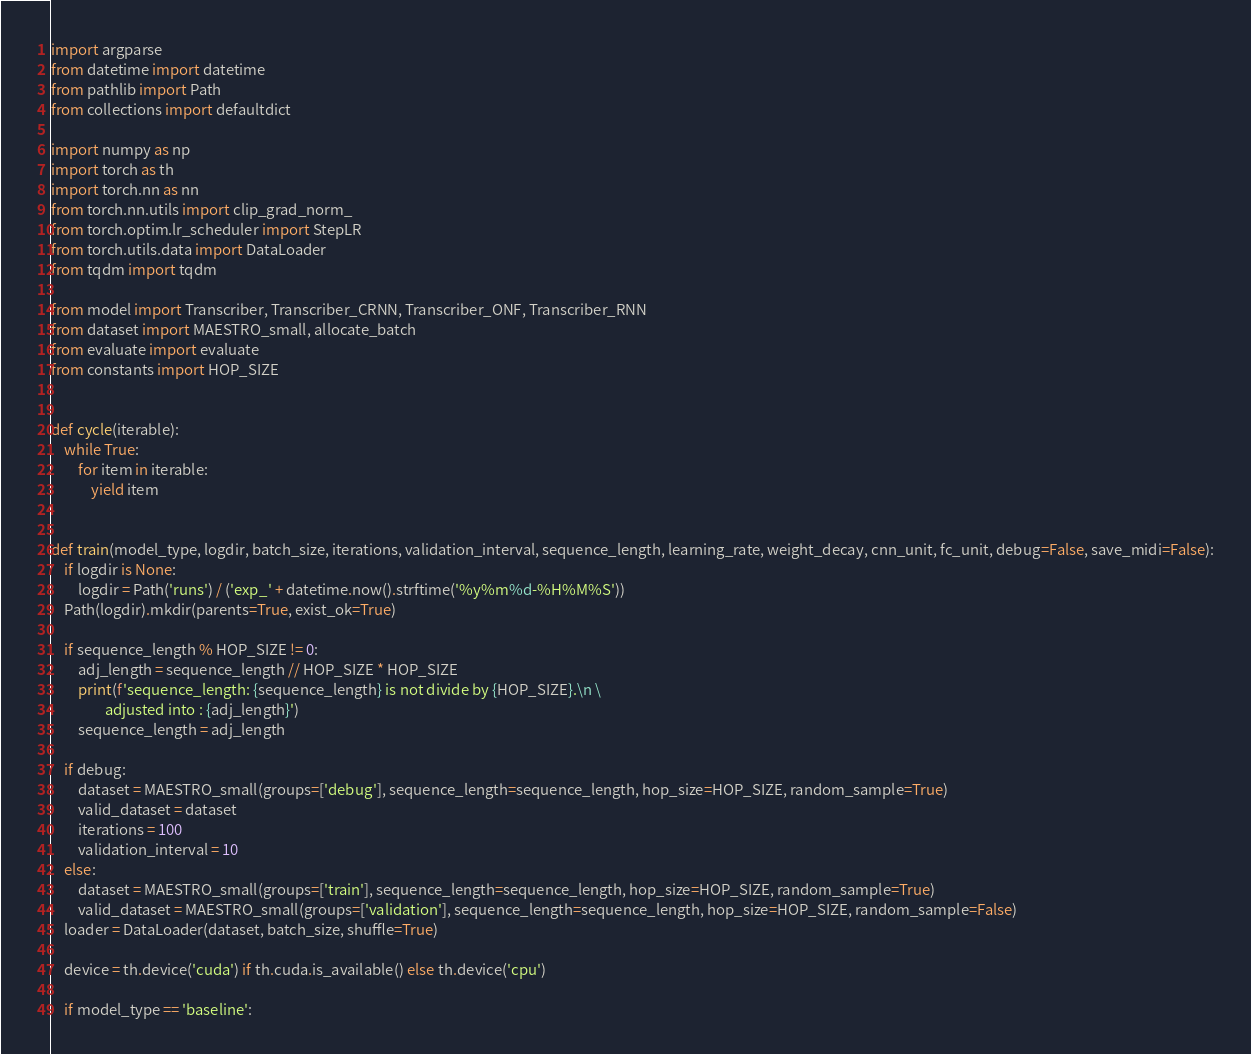<code> <loc_0><loc_0><loc_500><loc_500><_Python_>import argparse
from datetime import datetime
from pathlib import Path
from collections import defaultdict

import numpy as np
import torch as th
import torch.nn as nn
from torch.nn.utils import clip_grad_norm_
from torch.optim.lr_scheduler import StepLR
from torch.utils.data import DataLoader
from tqdm import tqdm

from model import Transcriber, Transcriber_CRNN, Transcriber_ONF, Transcriber_RNN
from dataset import MAESTRO_small, allocate_batch
from evaluate import evaluate
from constants import HOP_SIZE


def cycle(iterable):
    while True:
        for item in iterable:
            yield item


def train(model_type, logdir, batch_size, iterations, validation_interval, sequence_length, learning_rate, weight_decay, cnn_unit, fc_unit, debug=False, save_midi=False):
    if logdir is None:
        logdir = Path('runs') / ('exp_' + datetime.now().strftime('%y%m%d-%H%M%S'))
    Path(logdir).mkdir(parents=True, exist_ok=True)

    if sequence_length % HOP_SIZE != 0:
        adj_length = sequence_length // HOP_SIZE * HOP_SIZE
        print(f'sequence_length: {sequence_length} is not divide by {HOP_SIZE}.\n \
                adjusted into : {adj_length}')
        sequence_length = adj_length

    if debug:
        dataset = MAESTRO_small(groups=['debug'], sequence_length=sequence_length, hop_size=HOP_SIZE, random_sample=True)
        valid_dataset = dataset
        iterations = 100
        validation_interval = 10
    else:
        dataset = MAESTRO_small(groups=['train'], sequence_length=sequence_length, hop_size=HOP_SIZE, random_sample=True)
        valid_dataset = MAESTRO_small(groups=['validation'], sequence_length=sequence_length, hop_size=HOP_SIZE, random_sample=False)
    loader = DataLoader(dataset, batch_size, shuffle=True)

    device = th.device('cuda') if th.cuda.is_available() else th.device('cpu')

    if model_type == 'baseline':</code> 